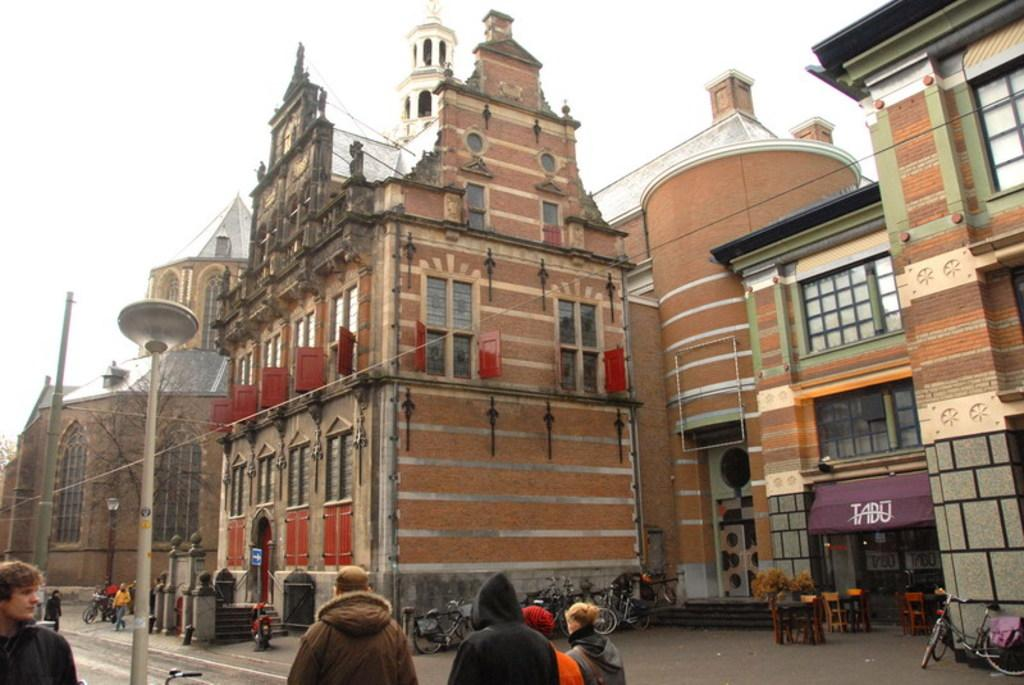What is happening on the road in the image? There is a crowd on the road in the image. What type of vehicles can be seen on the road? Bicycles are present on the road. What can be seen in the background of the image? There are buildings, wires, trees, windows, and the sky visible in the background. Where was the image taken? The image was taken on the road. How many rings are visible on the bicycles in the image? There are no rings visible on the bicycles in the image. What type of boats can be seen in the image? There are no boats present in the image. 